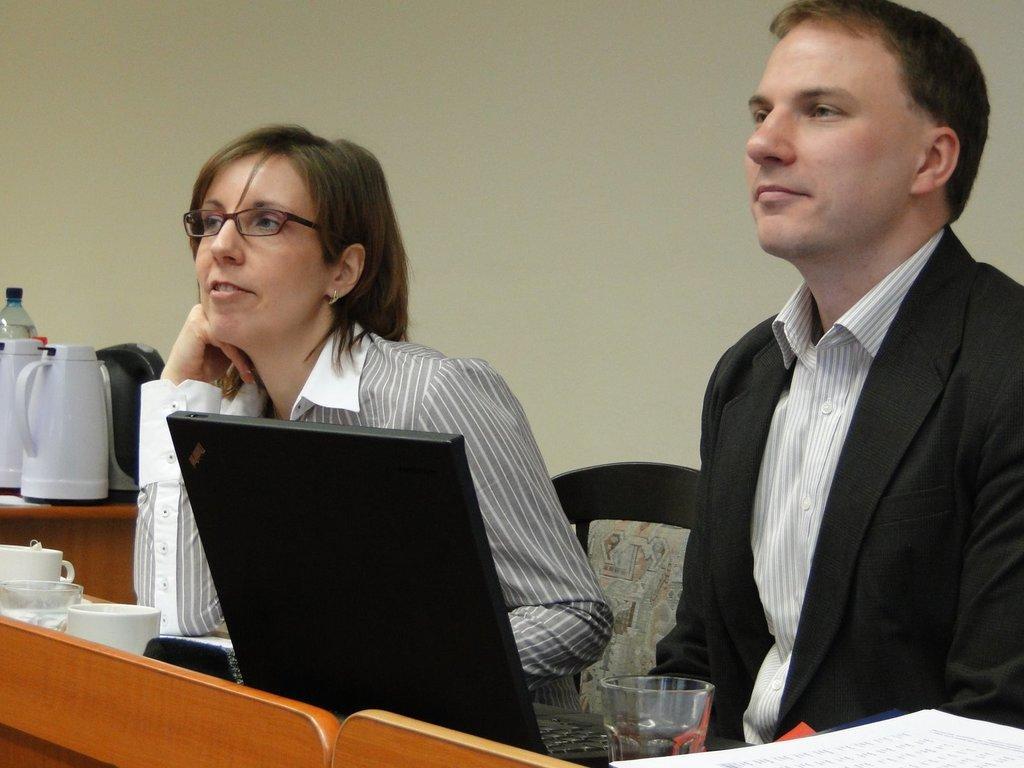Could you give a brief overview of what you see in this image? As we can see in the image there is a wall, chairs and two people sitting on chairs and on table there is a laptop and cups. 